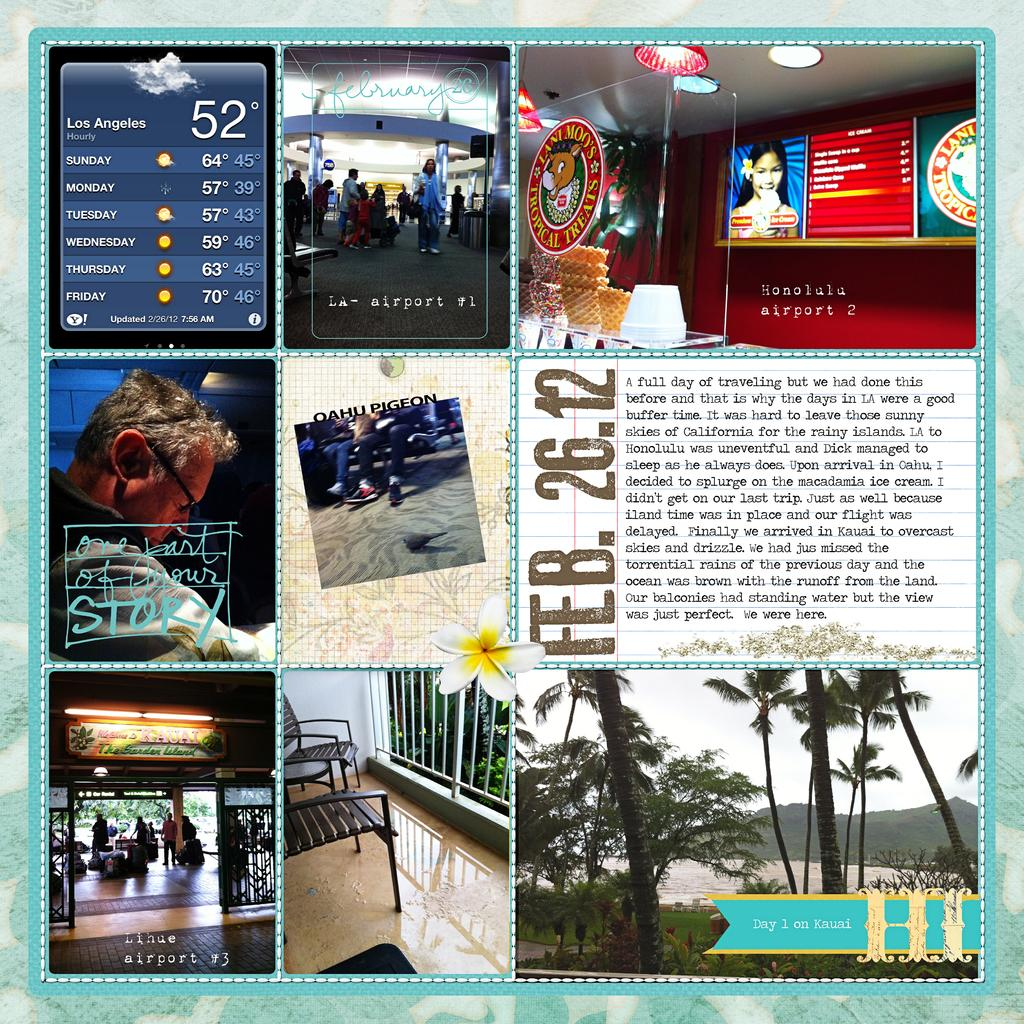What type of artwork is the image? The image is a collage. What natural elements can be seen in the collage? There are trees and flowers in the collage. What type of objects are present in the collage? There are frames and posters in the collage. Are there any human figures in the collage? Yes, there are persons in the collage. What type of leaf is used to create the frames in the collage? There are no leaves present in the collage, and the frames are not made of leaves. 